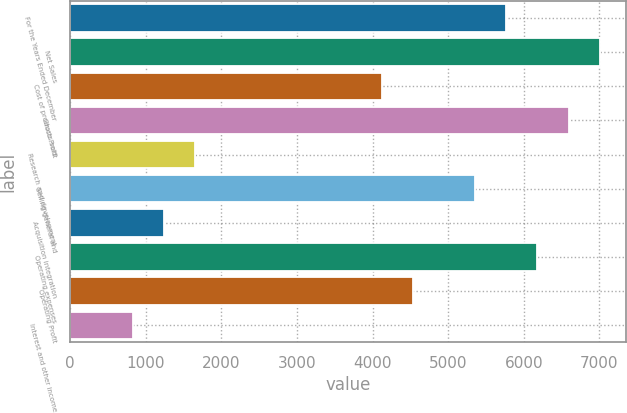Convert chart to OTSL. <chart><loc_0><loc_0><loc_500><loc_500><bar_chart><fcel>For the Years Ended December<fcel>Net Sales<fcel>Cost of products sold<fcel>Gross Profit<fcel>Research and development<fcel>Selling general and<fcel>Acquisition integration<fcel>Operating expenses<fcel>Operating Profit<fcel>Interest and other income<nl><fcel>5768.08<fcel>7003.3<fcel>4121.12<fcel>6591.56<fcel>1650.68<fcel>5356.34<fcel>1238.94<fcel>6179.82<fcel>4532.86<fcel>827.2<nl></chart> 